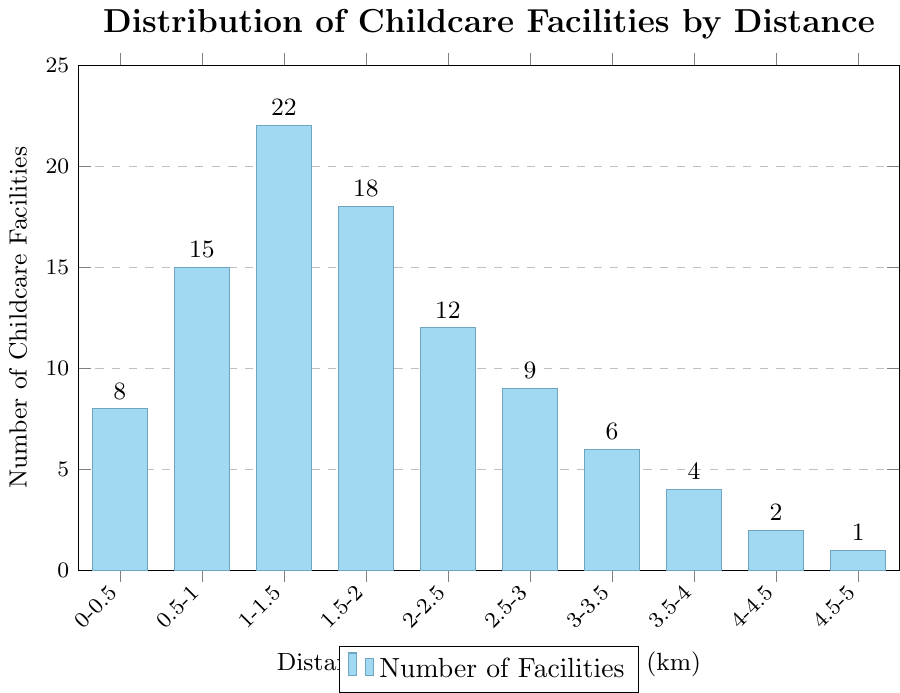How many childcare facilities are within 1-1.5 km of residential areas? Looking at the bar corresponding to the 1-1.5 km range, it reaches up to 22 facilities.
Answer: 22 Which distance range has the highest number of childcare facilities? By comparing the heights of all the bars, the tallest bar is at the 1-1.5 km range with 22 facilities.
Answer: 1-1.5 km Are there more childcare facilities within 1-1.5 km or within 2-2.5 km of residential areas? The bar for 1-1.5 km is higher with 22 facilities compared to the 2-2.5 km bar with 12 facilities.
Answer: 1-1.5 km What is the sum of childcare facilities between 0-1 km and 1-2 km? Adding the number of facilities in the ranges 0-0.5 km, 0.5-1 km, 1-1.5 km, and 1.5-2 km: 8 + 15 + 22 + 18 = 63.
Answer: 63 How does the number of facilities within 3-4 km compare to those within 0-1 km? The sum for 3-4 km is 6 + 4 = 10, while for 0-1 km it’s 8 + 15 = 23. Therefore, there are fewer facilities within 3-4 km than within 0-1 km.
Answer: Fewer What is the average number of childcare facilities within the whole 0-5 km range? Sum all the facility numbers and divide by the number of distance ranges: (8 + 15 + 22 + 18 + 12 + 9 + 6 + 4 + 2 + 1) / 10 = 97 / 10 = 9.7.
Answer: 9.7 Which range has the least number of childcare facilities, and what is the number? The smallest bar is at the 4.5-5 km range with 1 facility.
Answer: 4.5-5 km, 1 facility By how many facilities does the 1-1.5 km range exceed the 3-3.5 km range? Subtract the number of facilities in the 3-3.5 km range from that in the 1-1.5 km range: 22 - 6 = 16.
Answer: 16 What is the combined number of facilities for distance ranges greater than 3 km? Add the numbers for ranges 3-3.5 km, 3.5-4 km, 4-4.5 km, and 4.5-5 km: 6 + 4 + 2 + 1 = 13.
Answer: 13 Which range experiences the largest drop in the number of facilities compared to the previous range? Check the differences between consecutive bars; the largest drop is between 1.5-2 km (18 facilities) and 2-2.5 km (12 facilities), which is 18 - 12 = 6.
Answer: 1.5-2 km to 2-2.5 km, drop of 6 